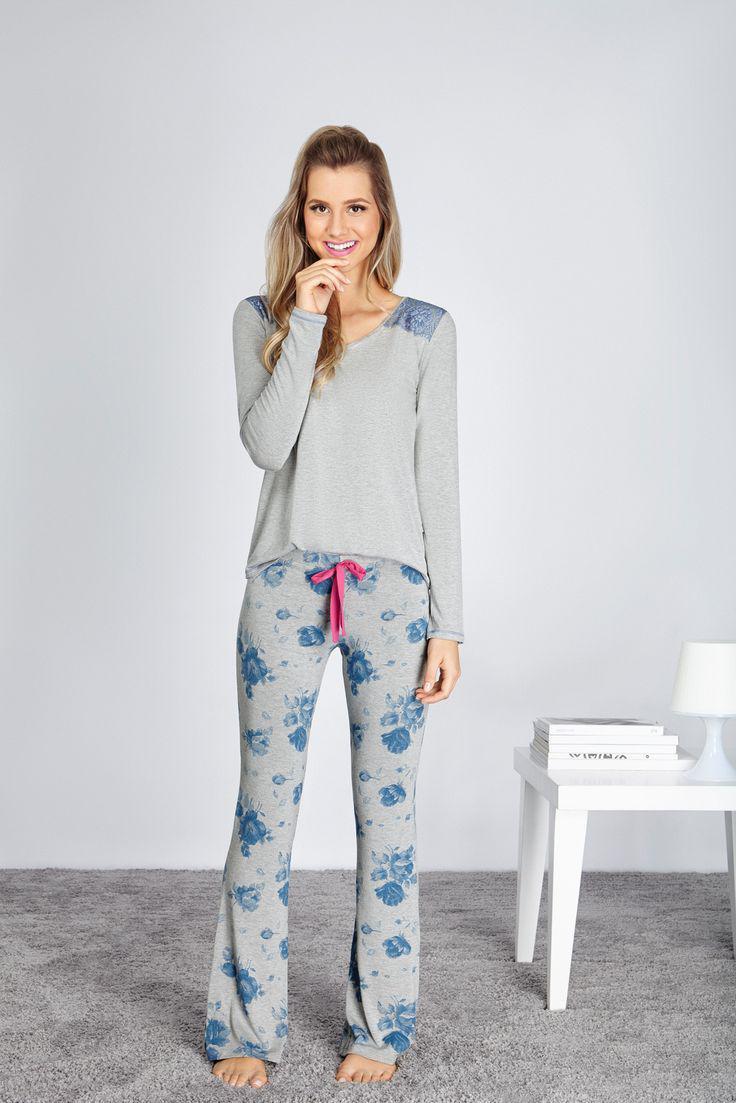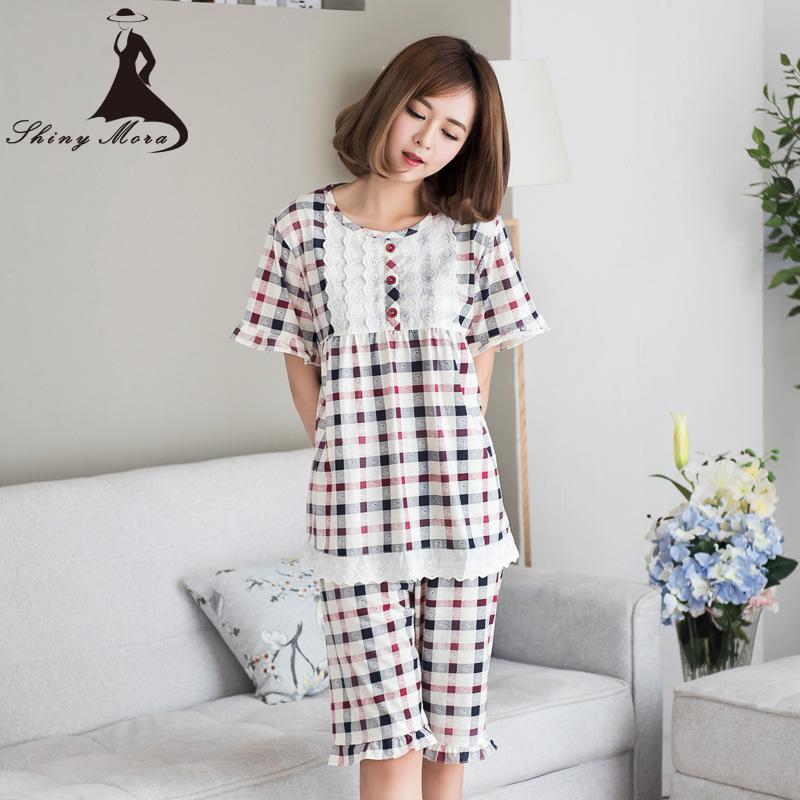The first image is the image on the left, the second image is the image on the right. Assess this claim about the two images: "The right image contains one person that is wearing predominately blue sleep wear.". Correct or not? Answer yes or no. No. 